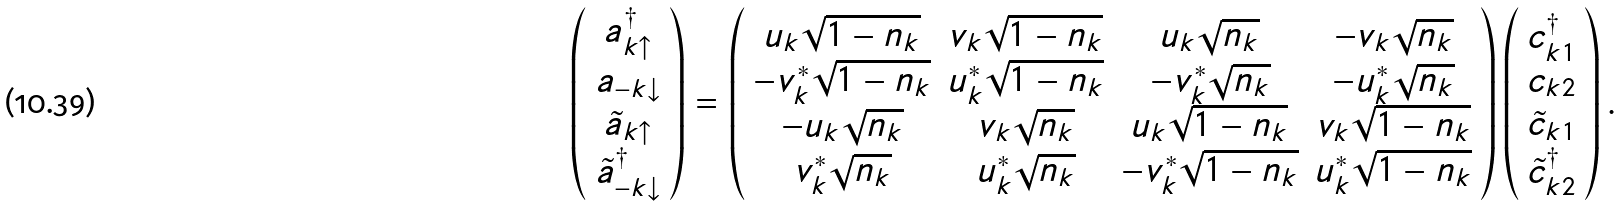<formula> <loc_0><loc_0><loc_500><loc_500>\left ( \begin{array} { c } a ^ { \dagger } _ { k \uparrow } \\ a _ { - k \downarrow } \\ \tilde { a } _ { k \uparrow } \\ \tilde { a } ^ { \dagger } _ { - k \downarrow } \\ \end{array} \right ) = \left ( \begin{array} { c c c c } u _ { k } \sqrt { 1 - n _ { k } } & v _ { k } \sqrt { 1 - n _ { k } } & u _ { k } \sqrt { n _ { k } } & - v _ { k } \sqrt { n _ { k } } \\ - v ^ { * } _ { k } \sqrt { 1 - n _ { k } } & u ^ { * } _ { k } \sqrt { 1 - n _ { k } } & - v ^ { * } _ { k } \sqrt { n _ { k } } & - u ^ { * } _ { k } \sqrt { n _ { k } } \\ - u _ { k } \sqrt { n _ { k } } & v _ { k } \sqrt { n _ { k } } & u _ { k } \sqrt { 1 - n _ { k } } & v _ { k } \sqrt { 1 - n _ { k } } \\ v ^ { * } _ { k } \sqrt { n _ { k } } & u ^ { * } _ { k } \sqrt { n _ { k } } & - v ^ { * } _ { k } \sqrt { 1 - n _ { k } } & u ^ { * } _ { k } \sqrt { 1 - n _ { k } } \\ \end{array} \right ) \left ( \begin{array} { c } c ^ { \dagger } _ { k 1 } \\ c _ { k 2 } \\ \tilde { c } _ { k 1 } \\ \tilde { c } ^ { \dagger } _ { k 2 } \\ \end{array} \right ) .</formula> 